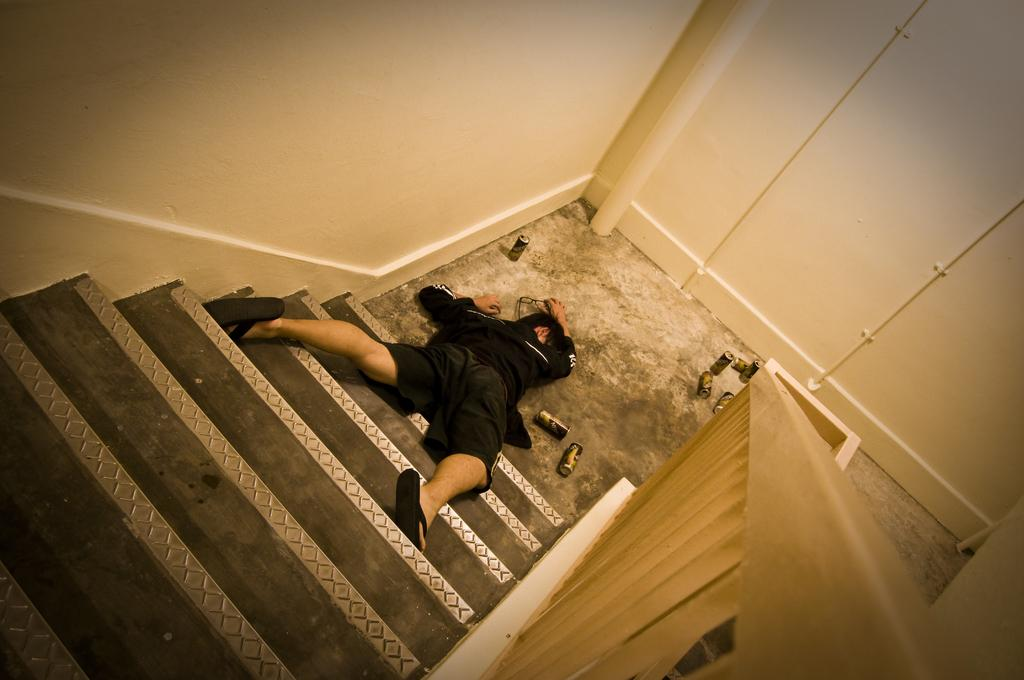What is the person in the image doing? The person is sleeping in the image. Where is the person sleeping? The person is on the stairs. What is the person wearing? The person is wearing a black dress. What can be seen in front of the person? There are tents in front of the person. What color is the wall in the background? The wall in the background is cream-colored. What caused the car to crash into the cave in the image? There is no car or cave present in the image; it features a person sleeping on the stairs with a cream-colored wall in the background and tents in front of them. 